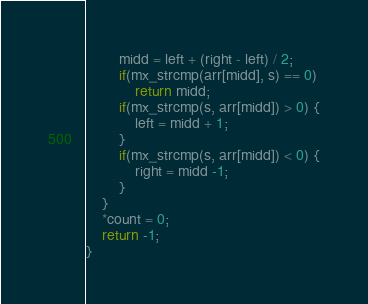<code> <loc_0><loc_0><loc_500><loc_500><_C_>        midd = left + (right - left) / 2;
        if(mx_strcmp(arr[midd], s) == 0)
            return midd;
        if(mx_strcmp(s, arr[midd]) > 0) {
            left = midd + 1;
        }
        if(mx_strcmp(s, arr[midd]) < 0) {
            right = midd -1;
        }
    }
    *count = 0;
    return -1;
}
</code> 